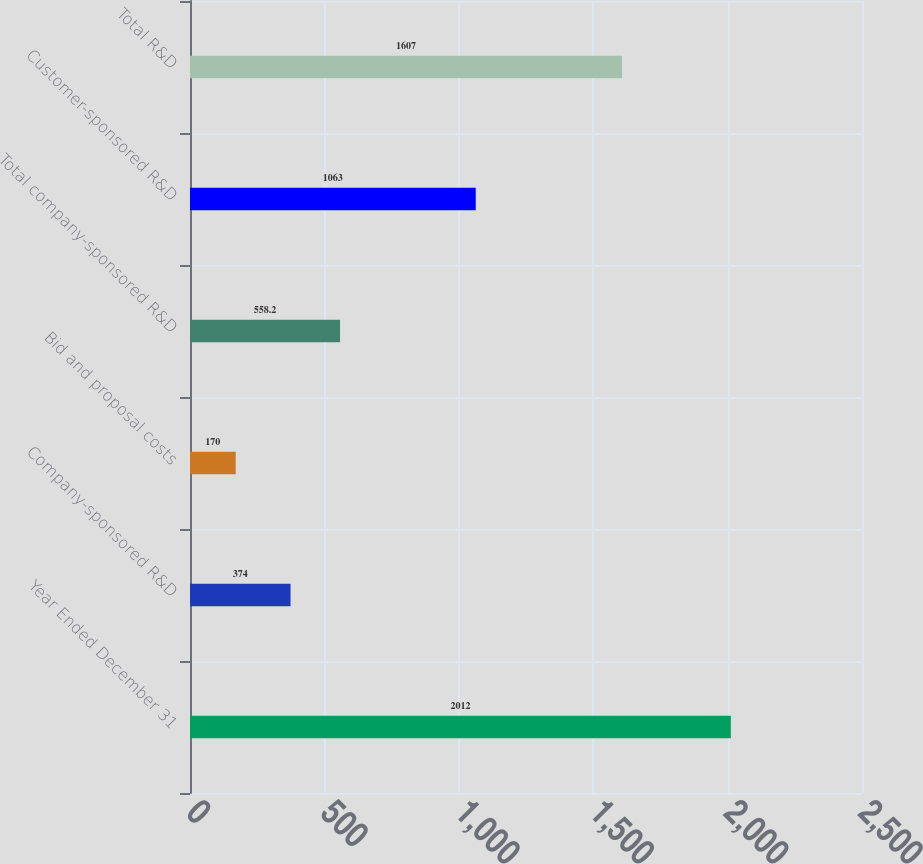Convert chart to OTSL. <chart><loc_0><loc_0><loc_500><loc_500><bar_chart><fcel>Year Ended December 31<fcel>Company-sponsored R&D<fcel>Bid and proposal costs<fcel>Total company-sponsored R&D<fcel>Customer-sponsored R&D<fcel>Total R&D<nl><fcel>2012<fcel>374<fcel>170<fcel>558.2<fcel>1063<fcel>1607<nl></chart> 